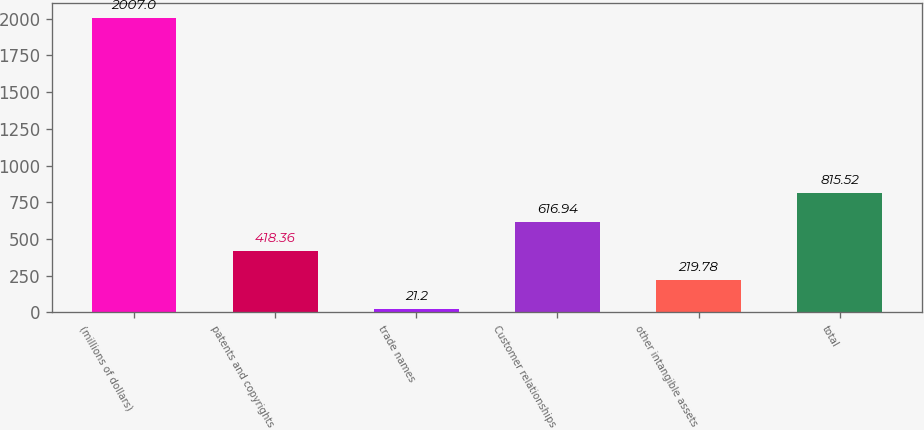Convert chart to OTSL. <chart><loc_0><loc_0><loc_500><loc_500><bar_chart><fcel>(millions of dollars)<fcel>patents and copyrights<fcel>trade names<fcel>Customer relationships<fcel>other intangible assets<fcel>total<nl><fcel>2007<fcel>418.36<fcel>21.2<fcel>616.94<fcel>219.78<fcel>815.52<nl></chart> 